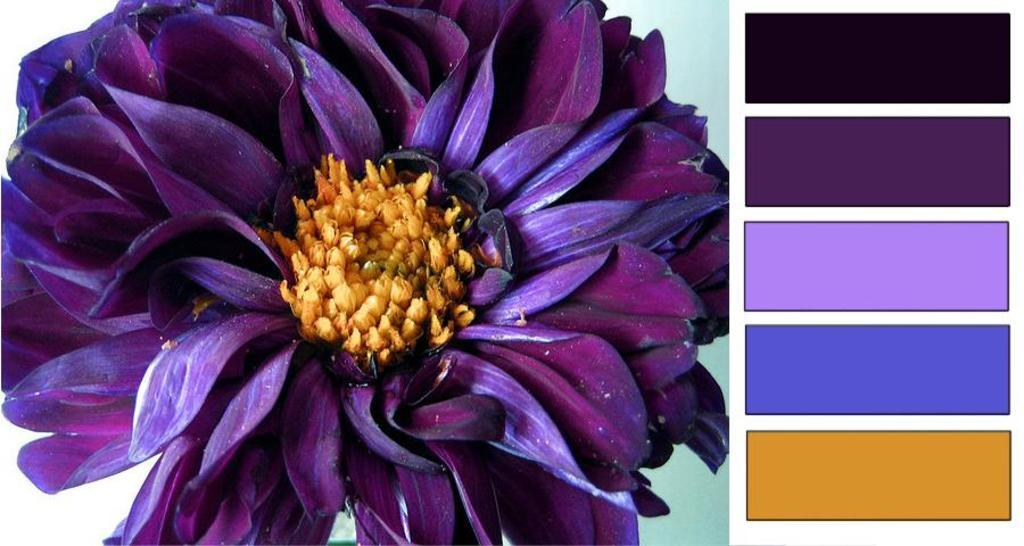What is the main subject of the image? There is a flower in the center of the image. What color is the flower? The flower is purple. What can be seen on the right side of the image? There are different colors on the right side of the image. What type of payment is required to answer the question about the flower's color? There is no payment required to answer any questions about the image, and the flower's color is already provided in the facts. 